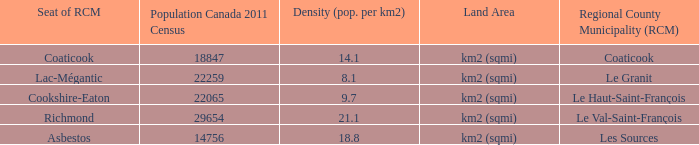What is the seat of the county that has a density of 14.1? Coaticook. 